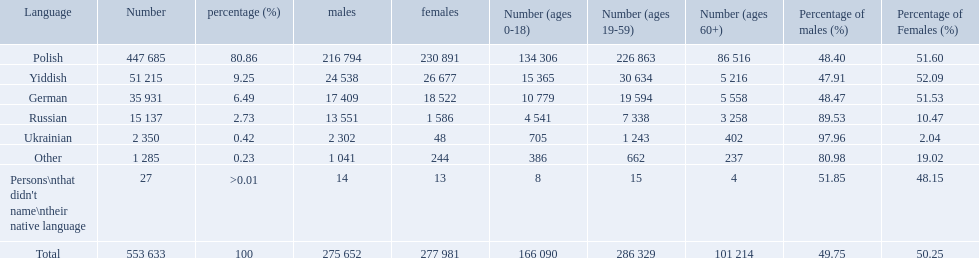What was the highest percentage of one language spoken by the plock governorate? 80.86. What language was spoken by 80.86 percent of the people? Polish. What languages are there? Polish, Yiddish, German, Russian, Ukrainian. What numbers speak these languages? 447 685, 51 215, 35 931, 15 137, 2 350. What numbers are not listed as speaking these languages? 1 285, 27. What are the totals of these speakers? 553 633. What were the languages in plock governorate? Polish, Yiddish, German, Russian, Ukrainian, Other. Which language has a value of .42? Ukrainian. 